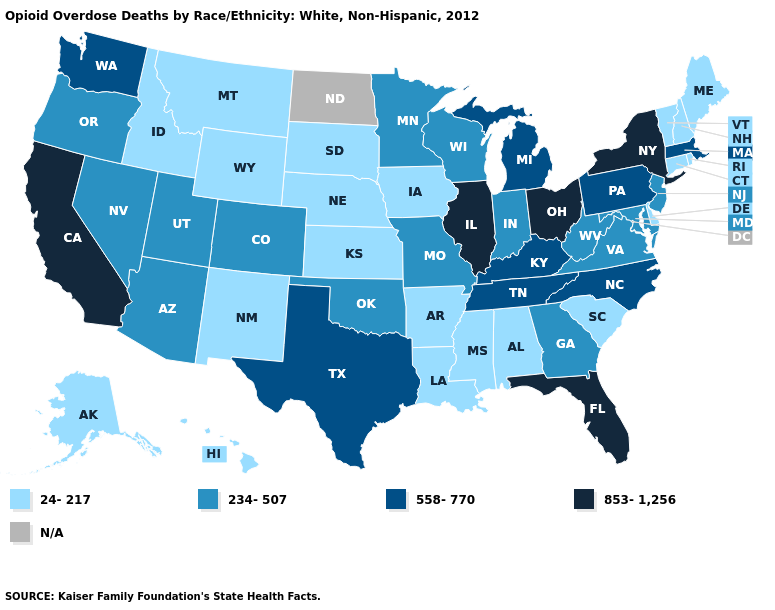Name the states that have a value in the range N/A?
Answer briefly. North Dakota. What is the value of Ohio?
Give a very brief answer. 853-1,256. What is the highest value in the Northeast ?
Keep it brief. 853-1,256. What is the value of Connecticut?
Give a very brief answer. 24-217. Which states have the highest value in the USA?
Be succinct. California, Florida, Illinois, New York, Ohio. Name the states that have a value in the range 853-1,256?
Answer briefly. California, Florida, Illinois, New York, Ohio. Among the states that border New York , which have the highest value?
Give a very brief answer. Massachusetts, Pennsylvania. Name the states that have a value in the range 558-770?
Answer briefly. Kentucky, Massachusetts, Michigan, North Carolina, Pennsylvania, Tennessee, Texas, Washington. What is the value of Maine?
Keep it brief. 24-217. Name the states that have a value in the range 853-1,256?
Be succinct. California, Florida, Illinois, New York, Ohio. Does the first symbol in the legend represent the smallest category?
Write a very short answer. Yes. What is the lowest value in the USA?
Concise answer only. 24-217. 